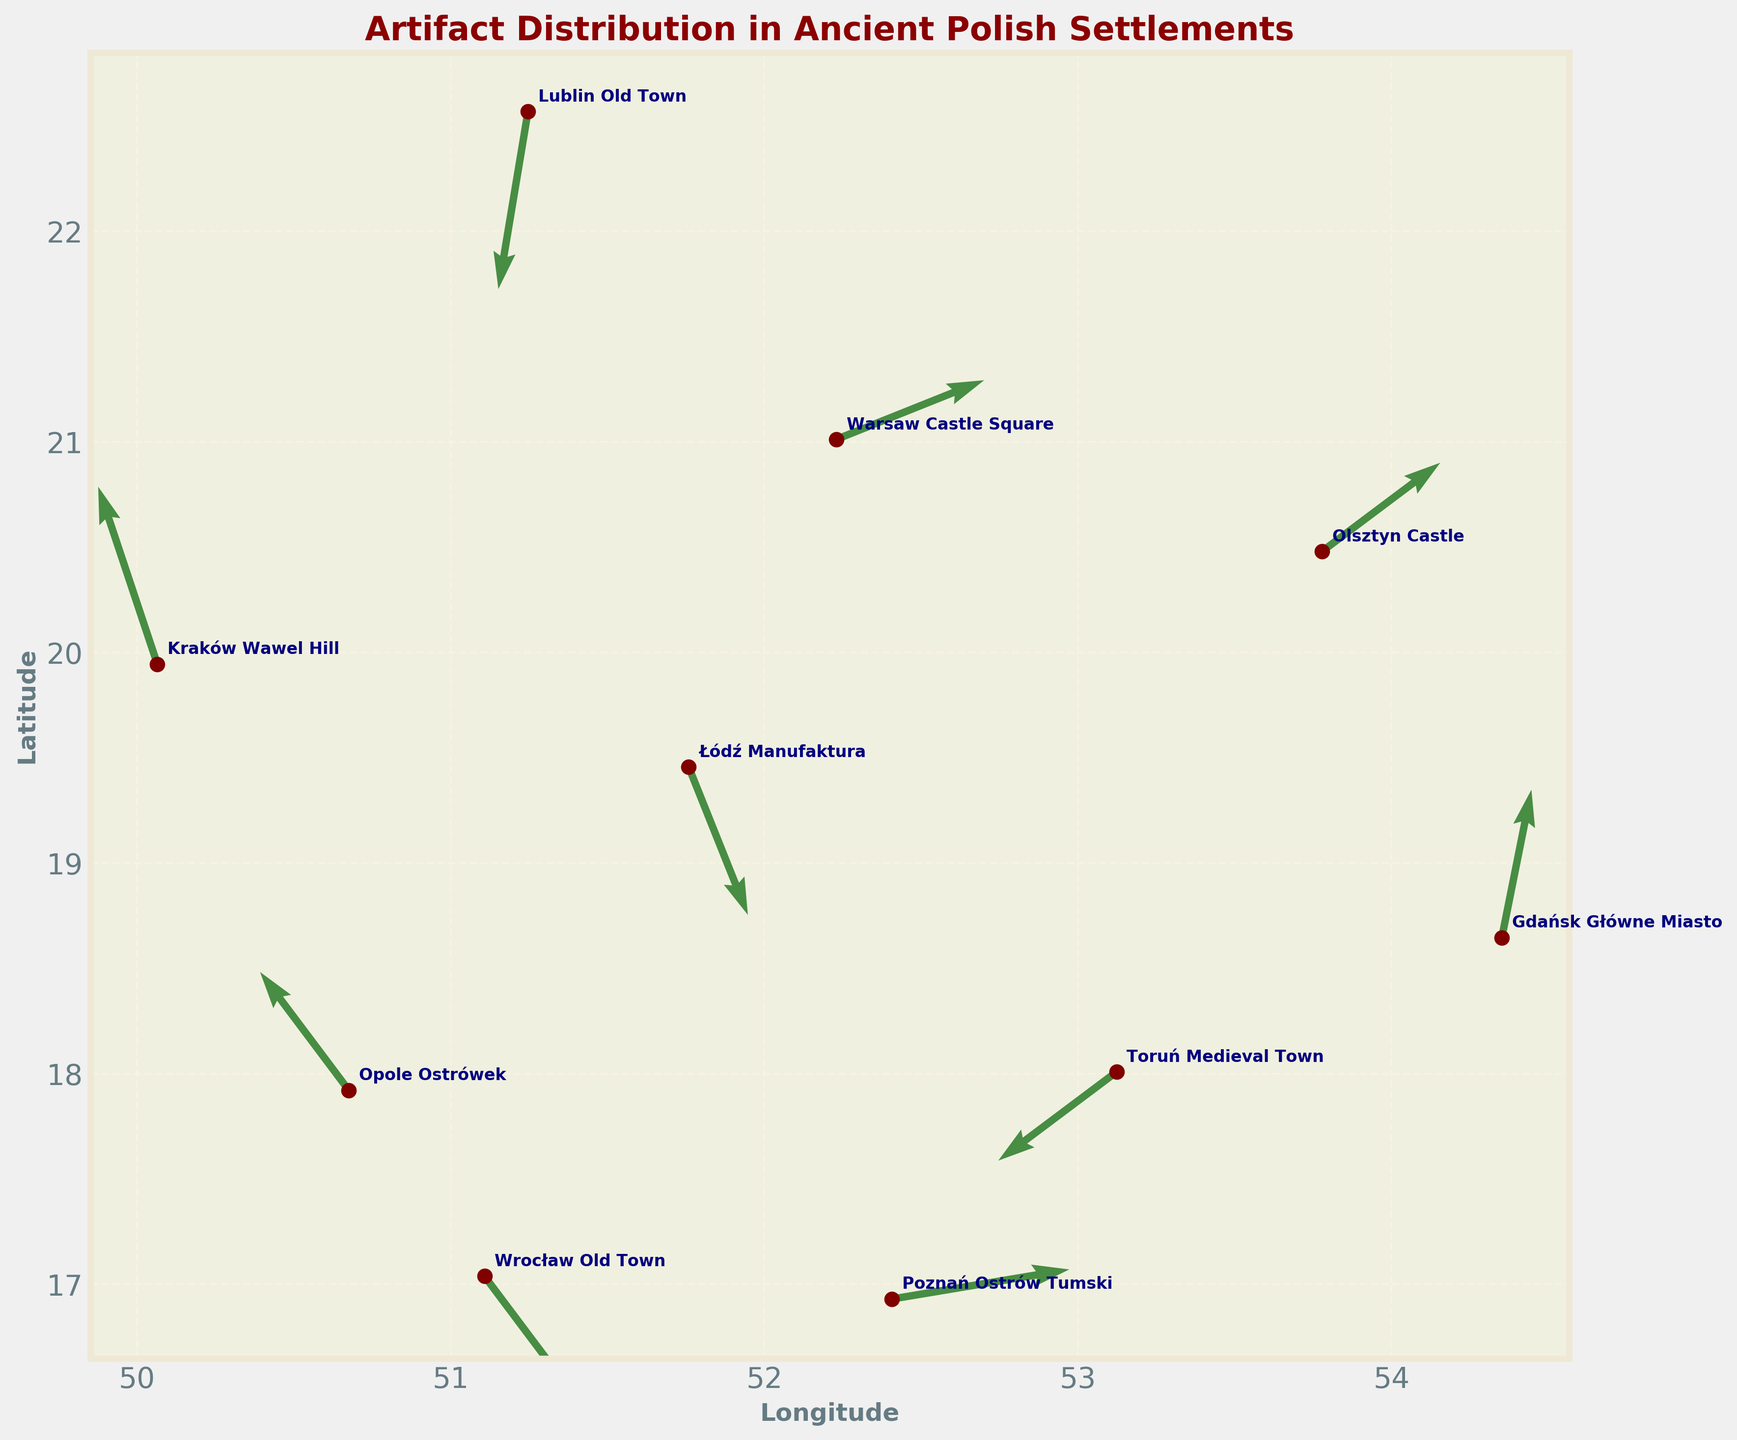What is the title of the plot? The title is usually placed at the top of the plot for easy identification. It helps provide context about what the plot represents. In this case, the title of the plot is "Artifact Distribution in Ancient Polish Settlements," which indicates that the plot shows data related to archeological excavation sites and artifact distributions in various Polish settlements.
Answer: Artifact Distribution in Ancient Polish Settlements How many archeological excavation sites are represented in the plot? To find the number of sites represented in the plot, you can count the number of scatter points or annotated site names. By looking at each point and its associated annotation, we see there are 10 sites.
Answer: 10 Which site has the highest positive movement in the x-direction? Positive movement in the x-direction is represented by a positive value of u. Comparing all the u values, we see the highest is 0.6 at Poznań Ostrów Tumski.
Answer: Poznań Ostrów Tumski Which two sites have movements almost in opposite directions? Opposite directions would mean the vectors point in significantly different directions. By examining the arrows, we can look for one site with a positive u and a negative v and another with a negative u and a positive v. Notably, Toruń Medieval Town (-0.4, -0.3) and Poznań Ostrów Tumski (0.6, 0.1) have movements in nearly opposite quadrants, though not exactly opposite.
Answer: Toruń Medieval Town and Poznań Ostrów Tumski What are the color and size of the scatter points marking the excavation sites? The scatter points marking the excavation sites are in a specific color and size for better visualization. By looking at the plot details, we can observe that the scatter points are maroon and appear to be moderately sized, about 50 units in the plotting dimension.
Answer: Maroon and 50 units Which site has the largest downward movement in the y-direction? Downward movement in the y-direction is indicated by a negative v value. Upon examining the values of v, Lublin Old Town has the largest negative v value of -0.6.
Answer: Lublin Old Town What is the average longitude of the sites? To calculate the average longitude, sum the longitude (x) values of all sites and divide by the number of sites (10). The longitudes are 51.1079, 52.2297, 50.0647, 54.3520, 53.1235, 51.7592, 52.4069, 50.6751, 53.7784, and 51.2465. Summing these gives 520.7449. Dividing by 10 gives an average longitude of 52.07449.
Answer: 52.07449 Which site has movement purely along the x-axis without any vertical movement? Purely x-axis movement means v=0 (no vertical component). On inspecting the data, none of the sites have a v value of exactly 0, indicating none have purely horizontal movement.
Answer: None What is the predominant color and patter used for the direction arrows in the plot? The direction arrows are designed to indicate movement or directional data. They are colored dark green, appear somewhat transparent (alpha set to 0.7), and have a specified pattern that makes them stand out against the rest of the plot.
Answer: Dark green with 70% opacity Which site is located at the highest latitude? Latitude corresponds to the y-axis values. The highest latitude can be identified by the highest y value. By comparing the latitudes, Gdańsk Główne Miasto has the highest latitude with a y value of 54.3520.
Answer: Gdańsk Główne Miasto 